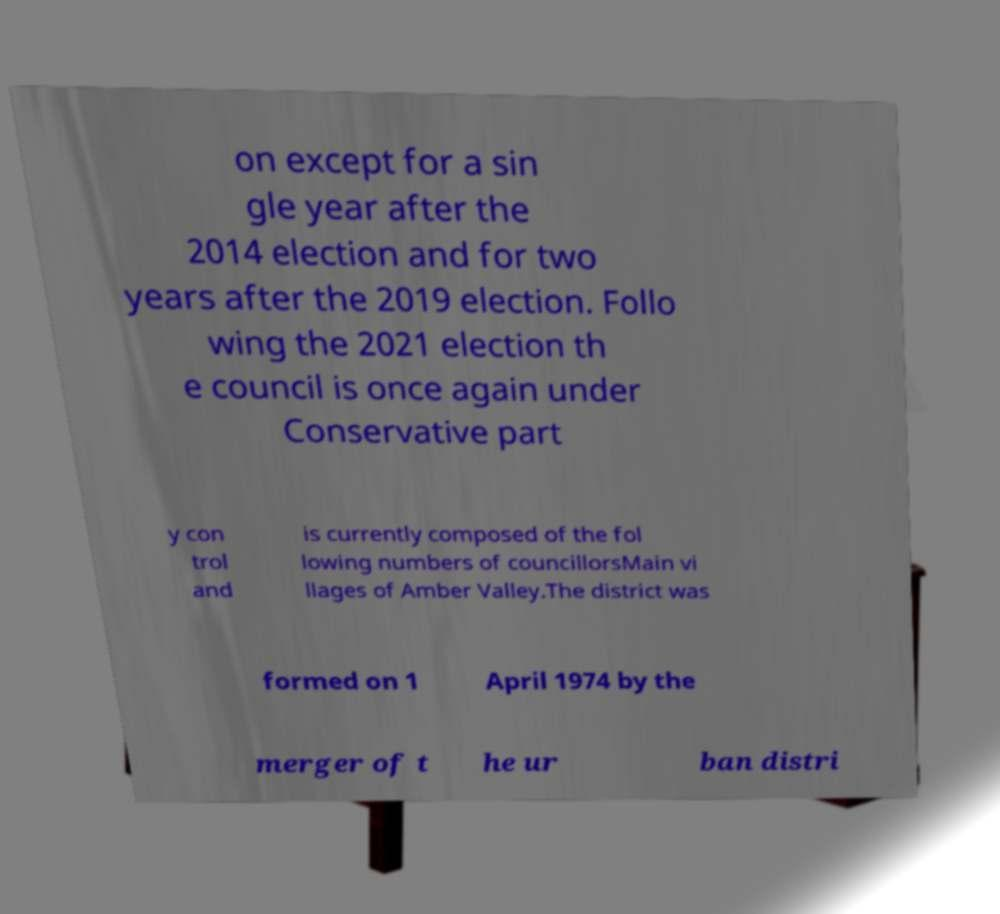Can you read and provide the text displayed in the image?This photo seems to have some interesting text. Can you extract and type it out for me? on except for a sin gle year after the 2014 election and for two years after the 2019 election. Follo wing the 2021 election th e council is once again under Conservative part y con trol and is currently composed of the fol lowing numbers of councillorsMain vi llages of Amber Valley.The district was formed on 1 April 1974 by the merger of t he ur ban distri 